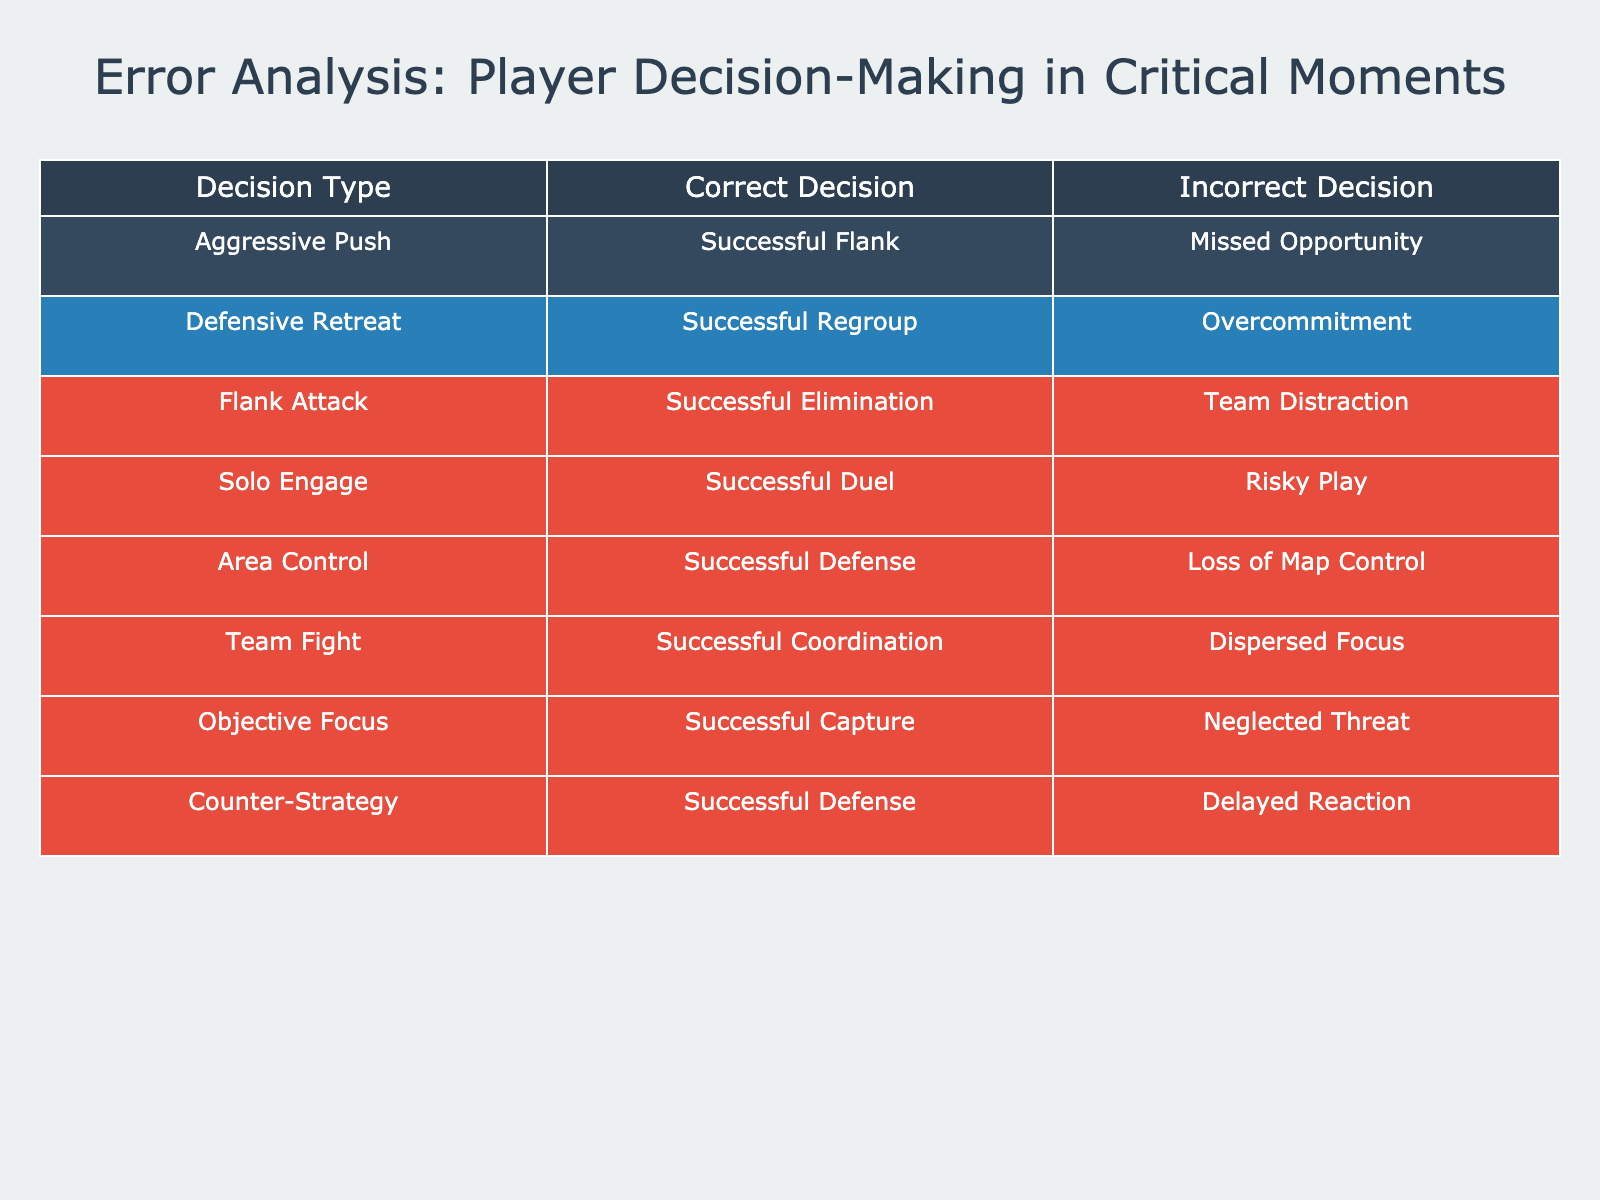What is the correct decision associated with "Solo Engage"? The table shows that the correct decision corresponding to "Solo Engage" is "Successful Duel." This value can be directly retrieved from the row associated with "Solo Engage."
Answer: Successful Duel How many total incorrect decisions are listed in the table? By examining the "Incorrect Decision" column, I can count the entries: "Missed Opportunity," "Overcommitment," "Team Distraction," "Risky Play," "Loss of Map Control," "Dispersed Focus," "Neglected Threat," and "Delayed Reaction." This gives us a total of 8 incorrect decisions.
Answer: 8 Is there an "Aggressive Push" in the correct decisions? The table lists "Successful Flank" as the correct decision for "Aggressive Push." Thus, there is confirmed presence of "Aggressive Push" with a correct decision.
Answer: Yes What is the ratio of successful decisions to total decisions for "Area Control"? For "Area Control," the successful decision is "Successful Defense," and there’s one corresponding decision in total for "Area Control." Thus, the ratio of successful decisions is 1 out of 1, which simplifies to 1:1.
Answer: 1:1 Which decision type has the most significant missed opportunity? Looking at the "Incorrect Decision" column, "Missed Opportunity" corresponds to the "Aggressive Push." Comparatively, it is the only specific mention of "missed opportunity" in the table, implying it is significant based on the terminology used.
Answer: Aggressive Push How many decisions display a "Successful Capture" as a correct outcome? The table indicates that "Successful Capture" corresponds solely to "Objective Focus." Therefore, this correct outcome appears only once in the table.
Answer: 1 If we combine the "Correct Decisions" for Team Fighting and Area Control, what decisions do we get? The "Correct Decision" for "Team Fight" is "Successful Coordination," and for "Area Control," it is "Successful Defense." Thus, combining these gives us "Successful Coordination" and "Successful Defense."
Answer: Successful Coordination, Successful Defense What can we infer about the "Counter-Strategy" decision from the table? The table indicates that the "Counter-Strategy" has a correct decision of "Successful Defense" and an incorrect decision of "Delayed Reaction." This means "Counter-Strategy" has a viable correct outcome but also carries a risk of delayed execution.
Answer: Successful Defense, Delayed Reaction 